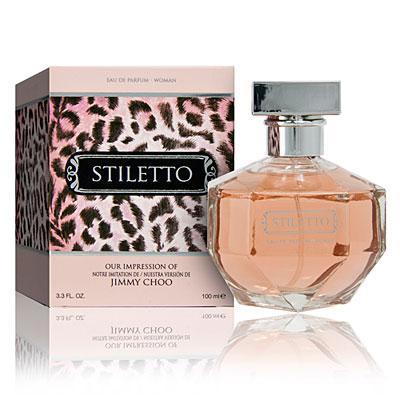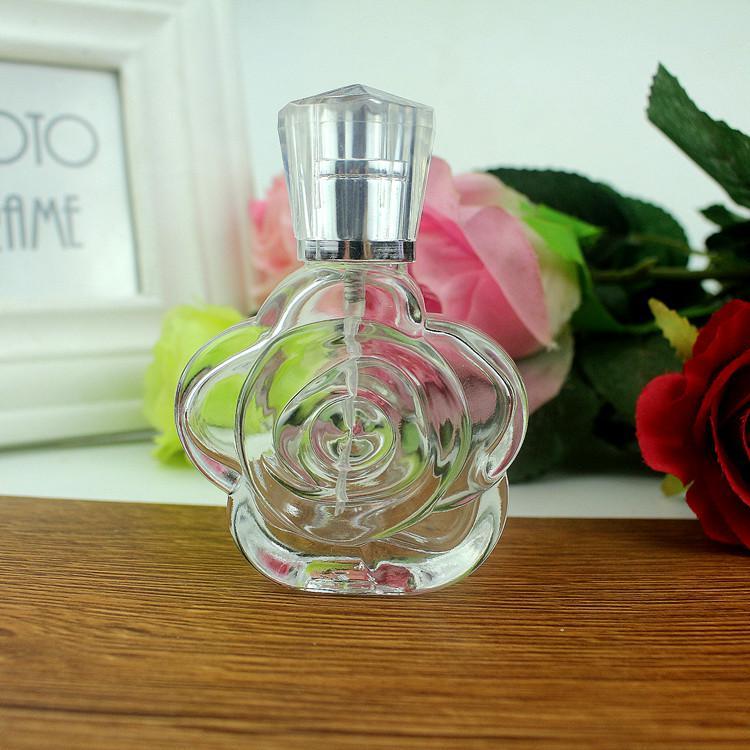The first image is the image on the left, the second image is the image on the right. Evaluate the accuracy of this statement regarding the images: "There is exactly one perfume bottle in the right image.". Is it true? Answer yes or no. Yes. The first image is the image on the left, the second image is the image on the right. Considering the images on both sides, is "An image shows exactly one fragrance standing to the right of its box." valid? Answer yes or no. Yes. 